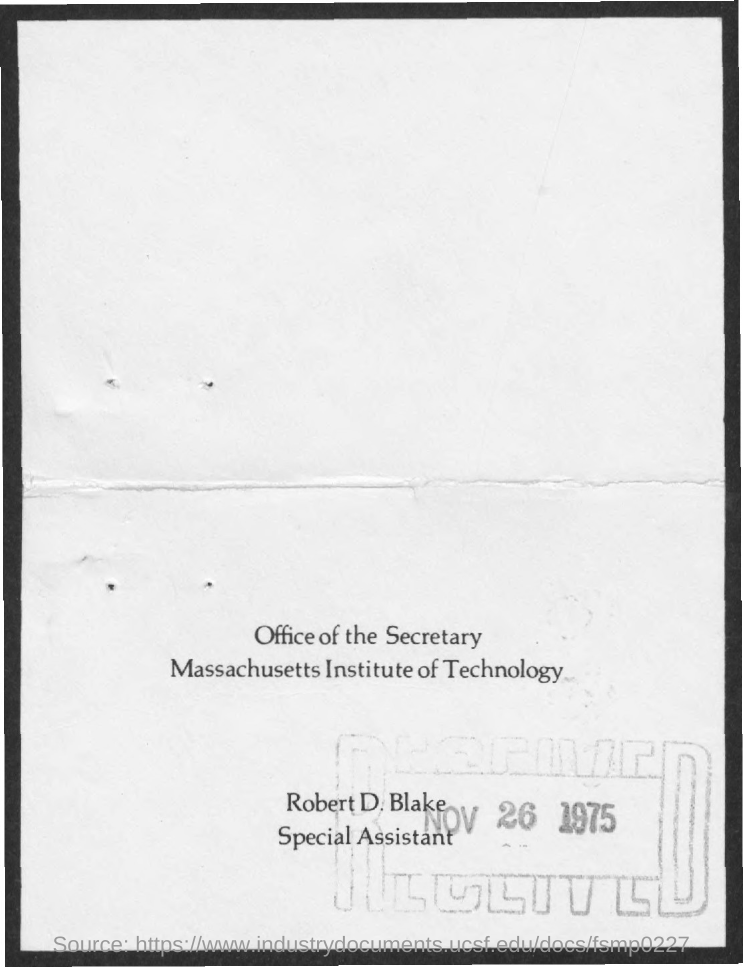Highlight a few significant elements in this photo. The Massachusetts Institute of Technology is named. Robert D. Blake is designated as a special assistant. The received date mentioned is November 26, 1975. 